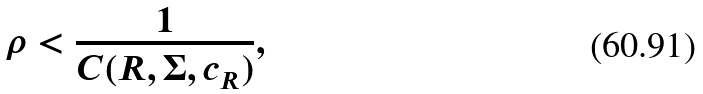<formula> <loc_0><loc_0><loc_500><loc_500>\rho < \frac { 1 } { C ( R , \Sigma , c _ { R } ) } ,</formula> 